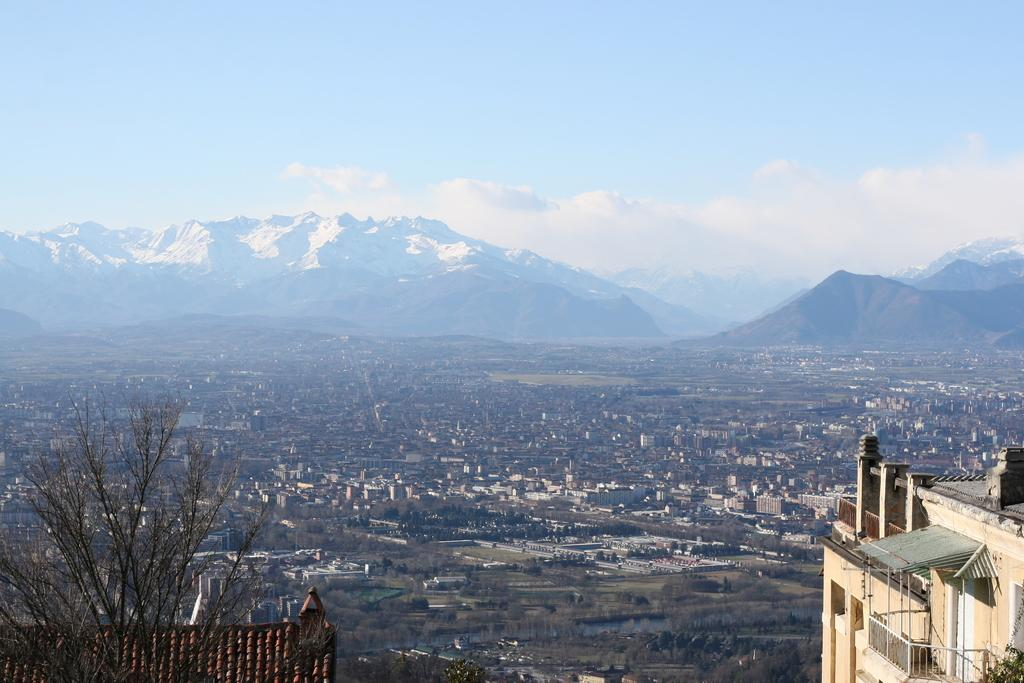What is located in the left bottom of the image? There is a dried tree and a roof top in the left bottom of the image. What type of structures can be seen in the image? There are buildings visible in the image. What can be seen in the background of the image? There are hills and the sky visible in the background of the image. What is the condition of the sky in the image? Clouds are present in the sky in the image. Where is the seat located in the image? There is no seat present in the image. What type of control is being used to manipulate the clouds in the image? There is no control present in the image, and the clouds are a natural phenomenon. 